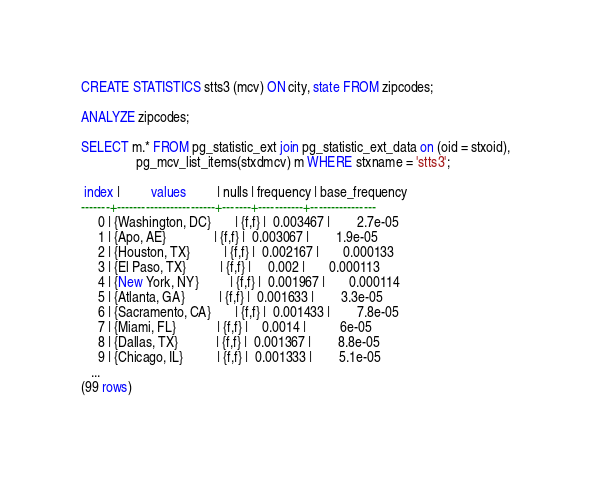Convert code to text. <code><loc_0><loc_0><loc_500><loc_500><_SQL_>CREATE STATISTICS stts3 (mcv) ON city, state FROM zipcodes;

ANALYZE zipcodes;

SELECT m.* FROM pg_statistic_ext join pg_statistic_ext_data on (oid = stxoid),
                pg_mcv_list_items(stxdmcv) m WHERE stxname = 'stts3';

 index |         values         | nulls | frequency | base_frequency 
-------+------------------------+-------+-----------+----------------
     0 | {Washington, DC}       | {f,f} |  0.003467 |        2.7e-05
     1 | {Apo, AE}              | {f,f} |  0.003067 |        1.9e-05
     2 | {Houston, TX}          | {f,f} |  0.002167 |       0.000133
     3 | {El Paso, TX}          | {f,f} |     0.002 |       0.000113
     4 | {New York, NY}         | {f,f} |  0.001967 |       0.000114
     5 | {Atlanta, GA}          | {f,f} |  0.001633 |        3.3e-05
     6 | {Sacramento, CA}       | {f,f} |  0.001433 |        7.8e-05
     7 | {Miami, FL}            | {f,f} |    0.0014 |          6e-05
     8 | {Dallas, TX}           | {f,f} |  0.001367 |        8.8e-05
     9 | {Chicago, IL}          | {f,f} |  0.001333 |        5.1e-05
   ...
(99 rows)
</code> 